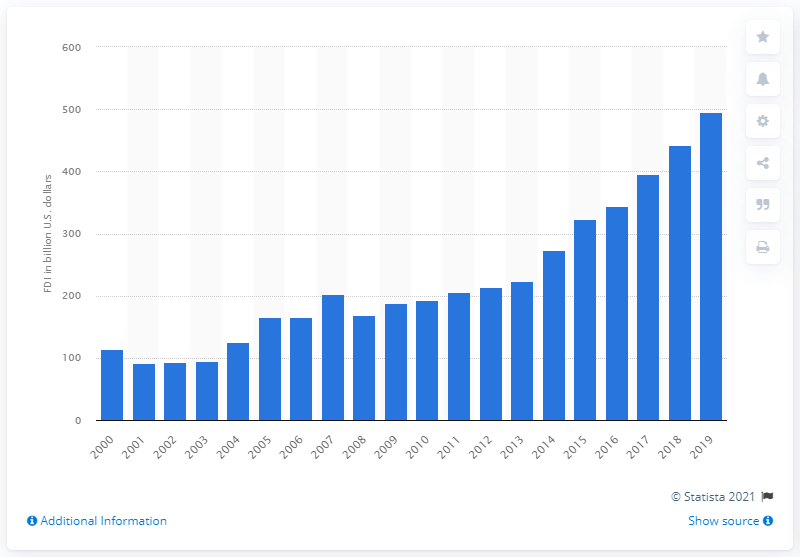Draw attention to some important aspects in this diagram. In 2019, the amount of Canadian foreign direct investments in the United States was approximately CAD 495.72. 